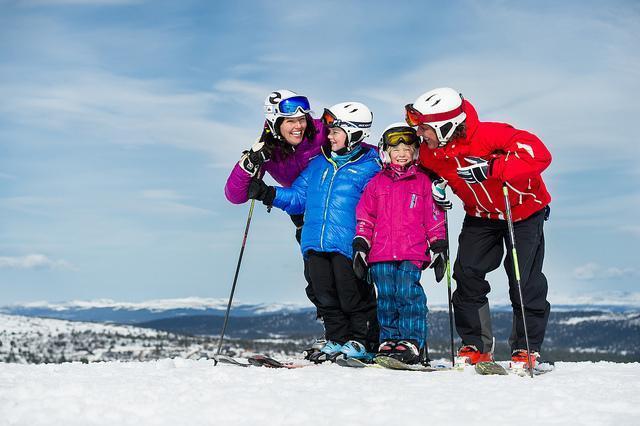How many skiers?
Give a very brief answer. 4. How many people are there?
Give a very brief answer. 4. 